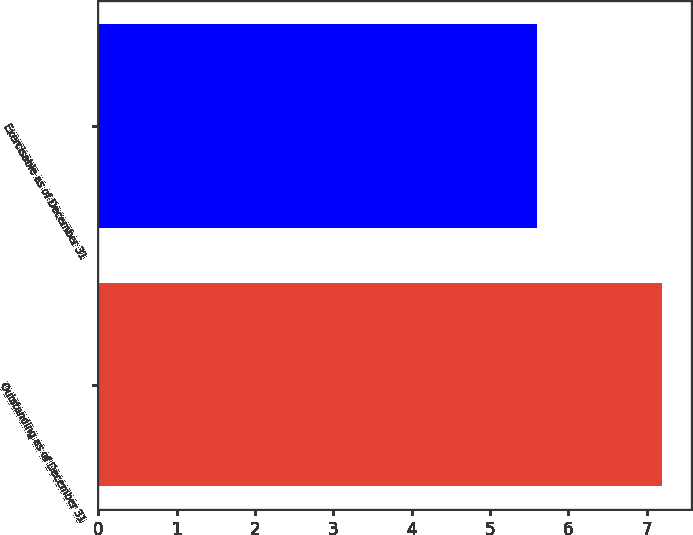Convert chart. <chart><loc_0><loc_0><loc_500><loc_500><bar_chart><fcel>Outstanding as of December 31<fcel>Exercisable as of December 31<nl><fcel>7.2<fcel>5.6<nl></chart> 